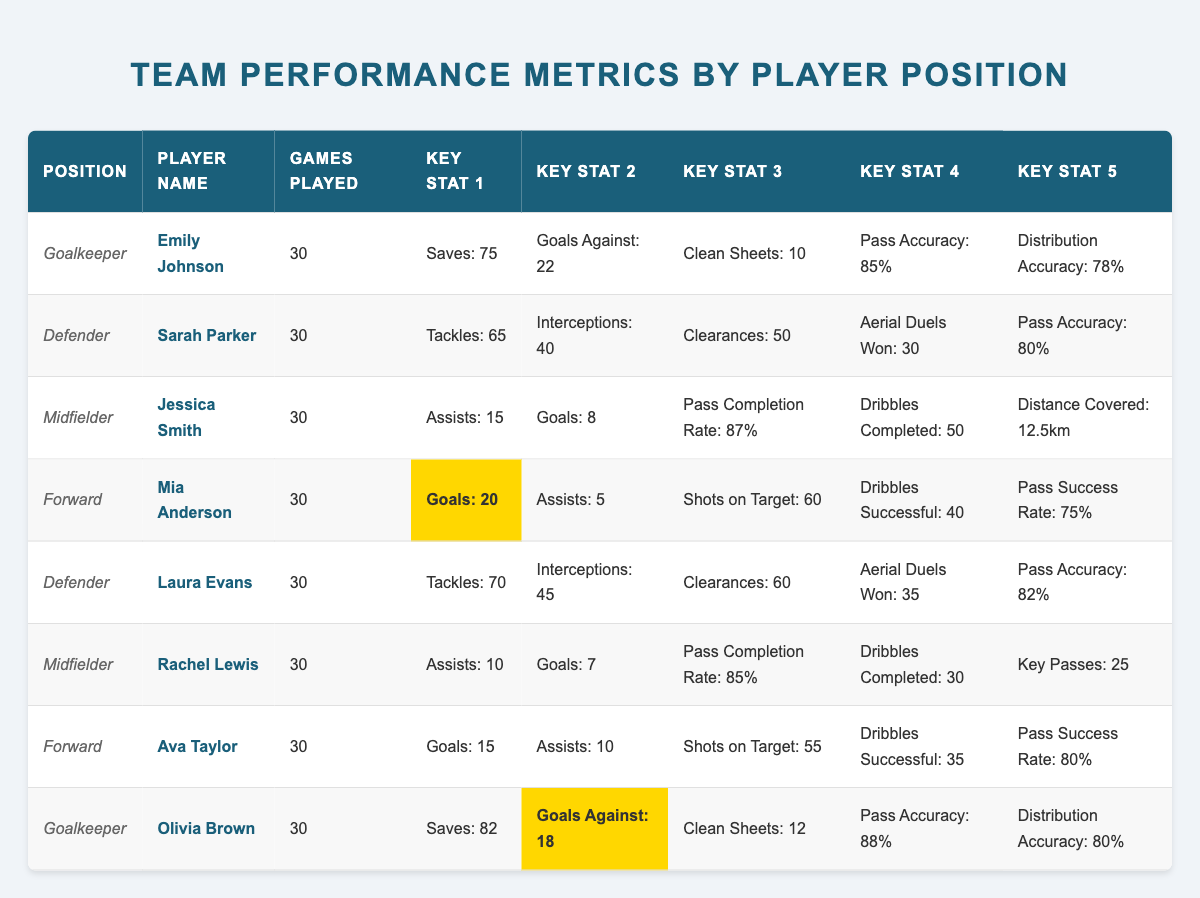What is the total number of saves made by the goalkeepers? From the table, Emily Johnson made 75 saves and Olivia Brown made 82 saves. Adding these together gives us 75 + 82 = 157 saves.
Answer: 157 Which defender had the highest number of tackles? The table lists tackles for Sarah Parker (65) and Laura Evans (70). Comparing these values, Laura Evans has the highest at 70 tackles.
Answer: Laura Evans How many assists did the forwards combined provide? Mia Anderson has 5 assists and Ava Taylor has 10 assists. Adding these two numbers together gives us 5 + 10 = 15 assists in total.
Answer: 15 Is Rachel Lewis a midfielder? Rachel Lewis is listed under the Midfielder position in the table, confirming that she is indeed a midfielder.
Answer: Yes What is the average goals scored by all forwards? Mia Anderson scored 20 goals and Ava Taylor scored 15 goals. The total is 20 + 15 = 35 goals. There are 2 forwards, so the average is 35 / 2 = 17.5.
Answer: 17.5 Which player has the best pass accuracy? Emily Johnson has a pass accuracy of 85%, Olivia Brown 88%, Sarah Parker 80%, Laura Evans 82%, Jessica Smith 87%, Rachel Lewis 85%, Mia Anderson 75%, and Ava Taylor 80%. Comparing these, Olivia Brown has the best at 88%.
Answer: Olivia Brown What is the total number of clean sheets recorded by the goalkeepers? Emily Johnson has 10 clean sheets and Olivia Brown has 12 clean sheets. Adding these together yields 10 + 12 = 22 clean sheets total for the goalkeepers.
Answer: 22 Did any midfielder score more goals than Rachel Lewis? Rachel Lewis scored 7 goals. The other midfielder, Jessica Smith, scored 8 goals. Since 8 is greater than 7, Jessica Smith scored more goals than Rachel Lewis.
Answer: Yes What is the difference in goals against between the two goalkeepers? Emily Johnson has 22 goals against, while Olivia Brown has 18. To find the difference, we subtract: 22 - 18 = 4.
Answer: 4 